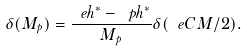Convert formula to latex. <formula><loc_0><loc_0><loc_500><loc_500>\delta ( M _ { p } ) = \frac { \ e h ^ { * } - \ p h ^ { * } } { M _ { p } } \delta ( \ e C M / 2 ) .</formula> 